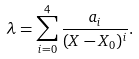Convert formula to latex. <formula><loc_0><loc_0><loc_500><loc_500>\lambda = \sum _ { i = 0 } ^ { 4 } \frac { a _ { i } } { ( X - X _ { 0 } ) ^ { i } } .</formula> 